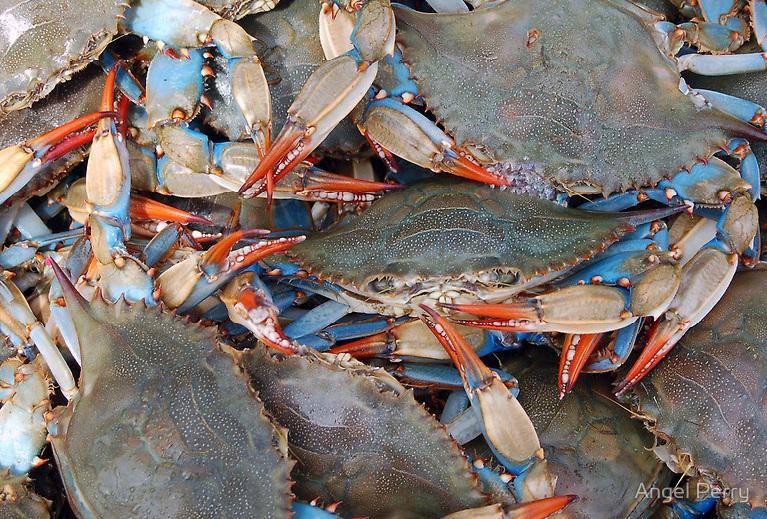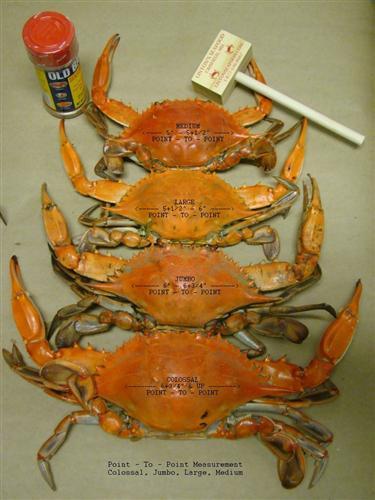The first image is the image on the left, the second image is the image on the right. Considering the images on both sides, is "All the crabs are on sand." valid? Answer yes or no. No. The first image is the image on the left, the second image is the image on the right. Analyze the images presented: Is the assertion "Each image contains one crab, and the crab on the left faces forward, while the crab on the right faces away from the camera." valid? Answer yes or no. No. 